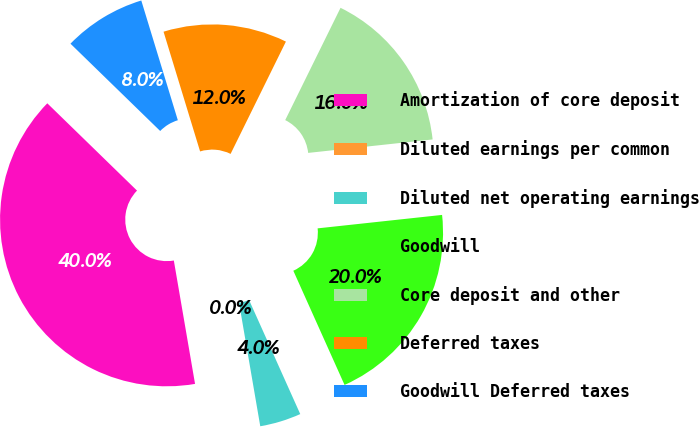<chart> <loc_0><loc_0><loc_500><loc_500><pie_chart><fcel>Amortization of core deposit<fcel>Diluted earnings per common<fcel>Diluted net operating earnings<fcel>Goodwill<fcel>Core deposit and other<fcel>Deferred taxes<fcel>Goodwill Deferred taxes<nl><fcel>39.99%<fcel>0.0%<fcel>4.0%<fcel>20.0%<fcel>16.0%<fcel>12.0%<fcel>8.0%<nl></chart> 